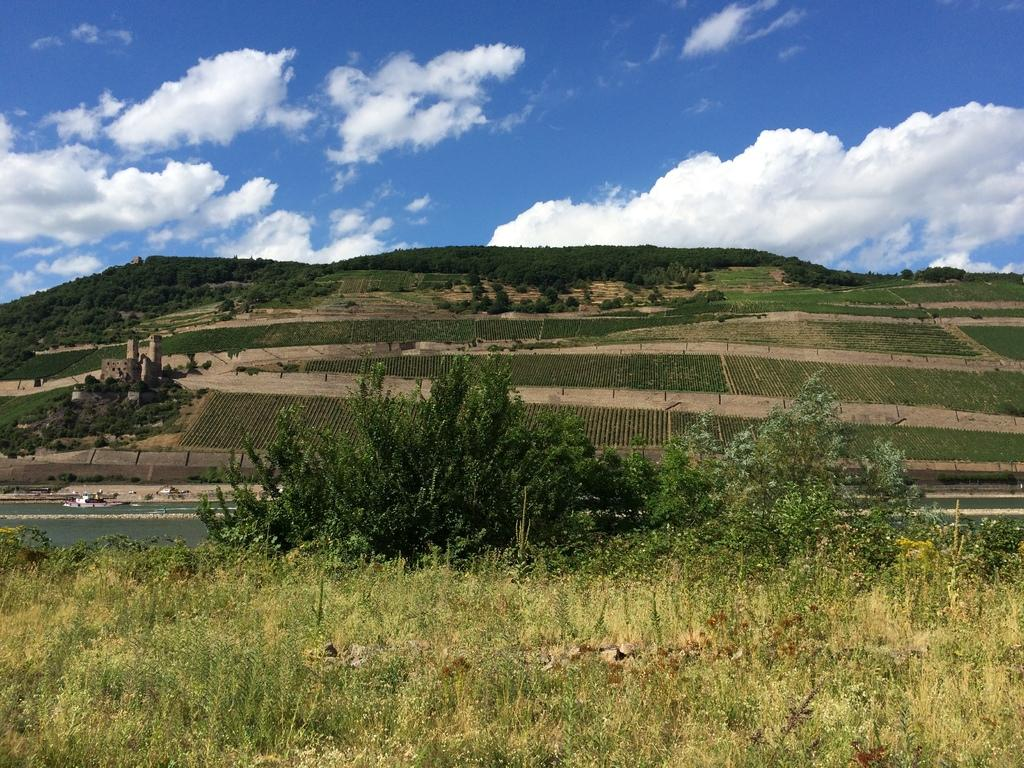What type of vegetation can be seen in the image? There are plants and trees in the image. What type of terrain is visible in the image? There are grasslands and hills in the image. What is the color of the sky in the background? The sky is blue in the background. What can be seen in the sky? There are clouds in the sky. Where is the pancake located in the image? There is no pancake present in the image. What type of scale is used to measure the size of the clouds in the image? There is no scale present in the image, and the size of the clouds cannot be measured. 